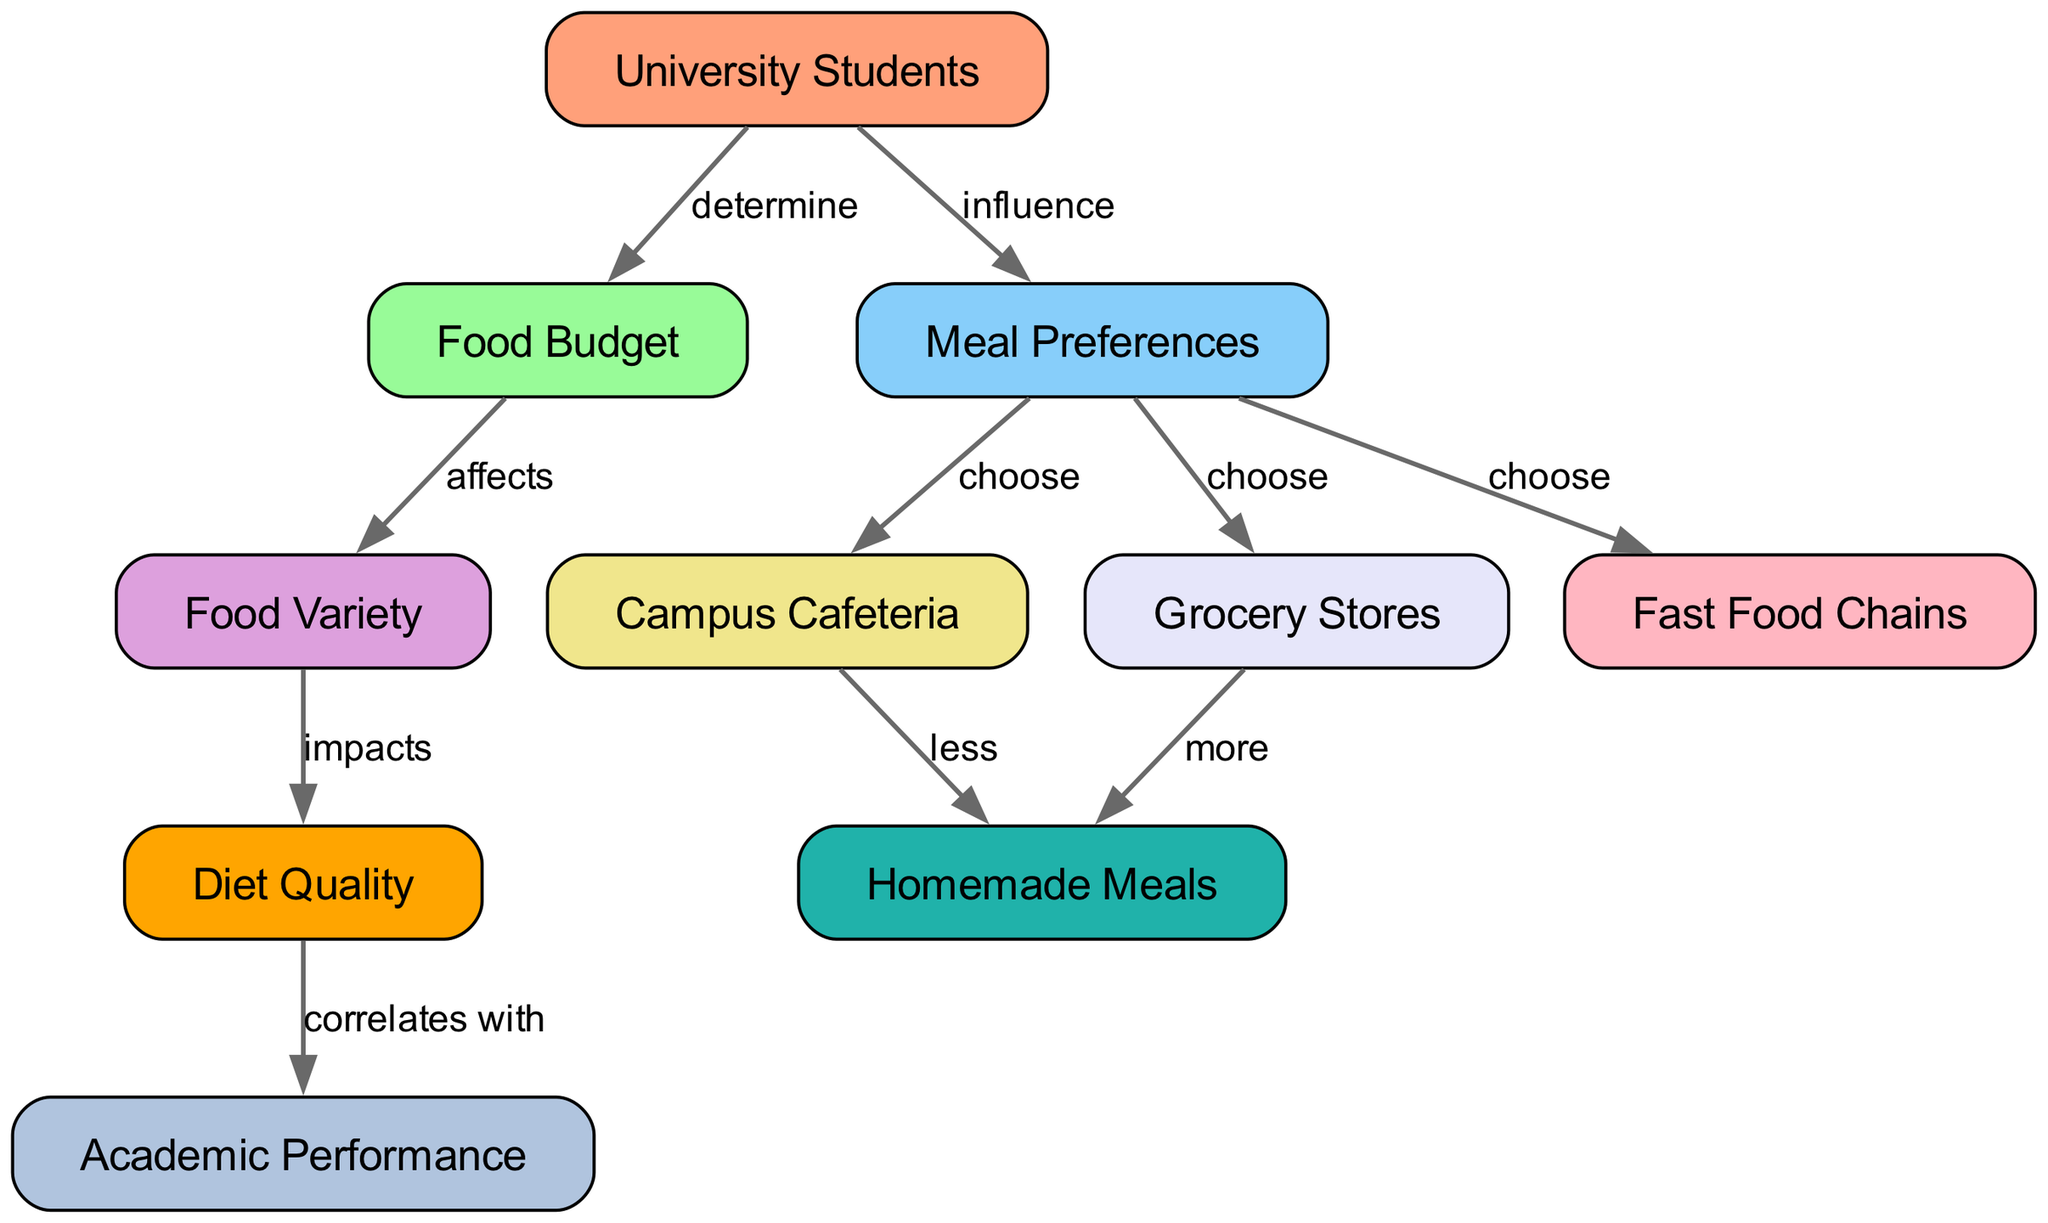What is the total number of nodes in the diagram? The diagram lists 10 nodes representing various aspects of the dietary habits of university students. These nodes include "University Students," "Food Budget," "Meal Preferences," "Food Variety," "Campus Cafeteria," "Grocery Stores," "Fast Food Chains," "Homemade Meals," "Diet Quality," and "Academic Performance." Counting all of them gives a total of 10.
Answer: 10 Which node determines the food budget? The node "University Students" is indicated to have a direct influence on determining the "Food Budget." This is explicitly stated in the diagram's relationships between the nodes.
Answer: University Students How do meal preferences affect the campus cafeteria? The diagram shows that "Meal Preferences" directly impact the choice of "Campus Cafeteria." This means that the specific meal preferences of university students guide their decisions on where to eat on campus.
Answer: choose What is the relationship between food variety and diet quality? The diagram illustrates that "Food Variety" impacts "Diet Quality." This indicates that having a variety in food choices contributes to the overall quality of the diet.
Answer: impacts If a student shops at grocery stores instead of campus cafeterias, what type of meals are they likely to have more of? According to the diagram, students who choose "Grocery Stores" have more "Homemade Meals," indicating that grocery shopping leads to increased preparation of meals at home as opposed to eating out.
Answer: more How many options are available for meal choices from meal preferences? The diagram shows that from "Meal Preferences," students can choose three options: "Campus Cafeteria," "Grocery Stores," and "Fast Food Chains." Counting these options gives a total of three distinct choices.
Answer: 3 Which factor correlates with academic performance? The diagram clearly states that "Diet Quality" correlates with "Academic Performance," suggesting that a better dietary quality may lead to improved academic outcomes for university students.
Answer: Diet Quality What effect does the food budget have on food variety? The diagram states that "Food Budget" affects "Food Variety." This means that the amount of money students are willing or able to spend on food has a direct impact on the range of food options they can afford.
Answer: affects What type of meals do students tend to eat less of if they frequently choose campus cafeterias? The diagram indicates that students who choose "Campus Cafeteria" tend to have "less" "Homemade Meals," suggesting that eating on-campus reduces their likelihood of preparing meals at home.
Answer: less What does diet quality impact according to the diagram? The diagram establishes that "Diet Quality" impacts "Academic Performance," meaning that the quality of diet among university students may influence their performance in academic settings.
Answer: Academic Performance 